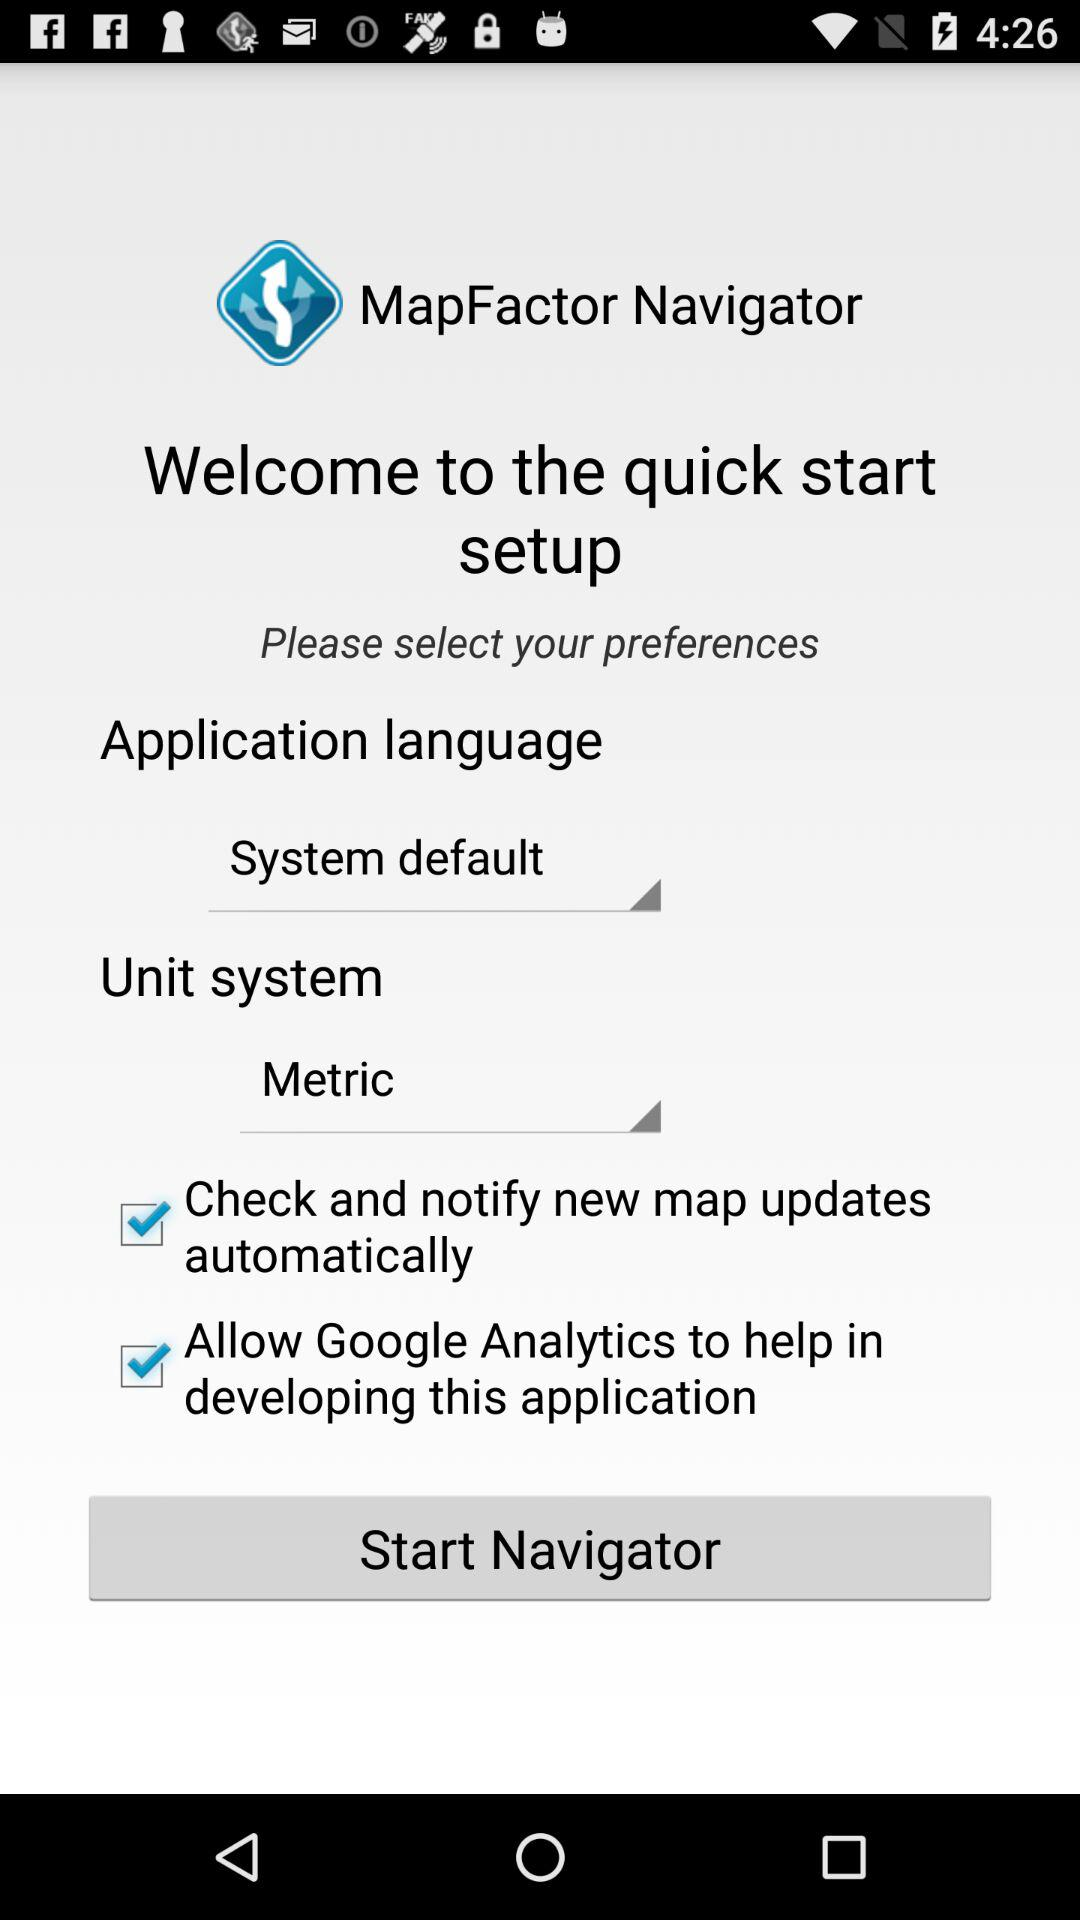What is the selected application language? The selected application language is "System default". 